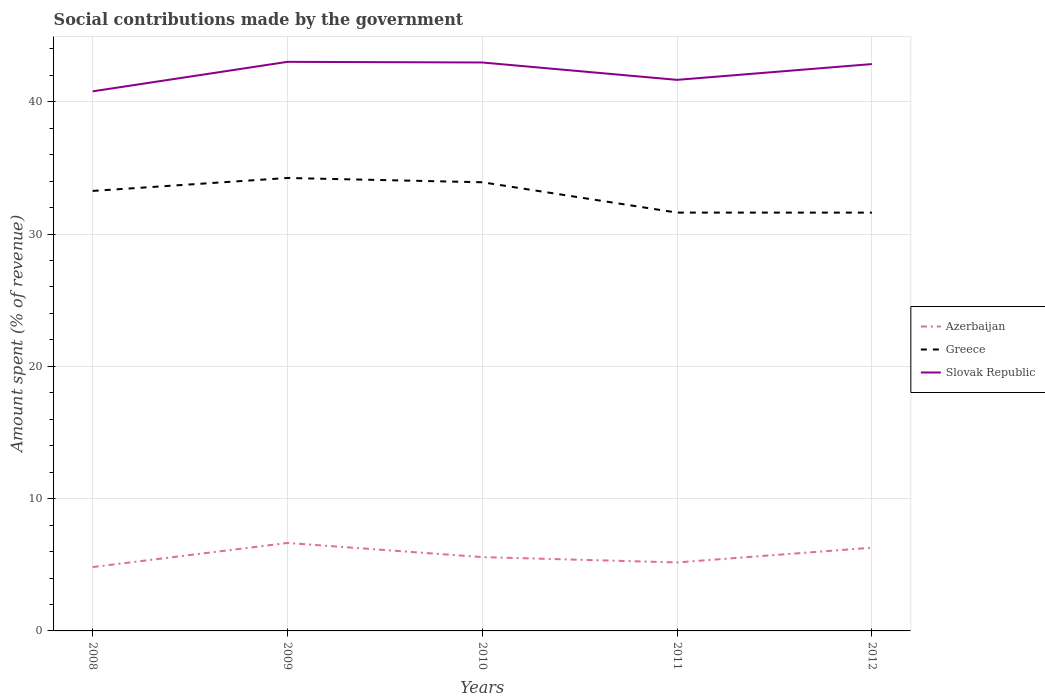Across all years, what is the maximum amount spent (in %) on social contributions in Slovak Republic?
Offer a terse response. 40.79. What is the total amount spent (in %) on social contributions in Azerbaijan in the graph?
Keep it short and to the point. 0.36. What is the difference between the highest and the second highest amount spent (in %) on social contributions in Azerbaijan?
Offer a very short reply. 1.82. What is the difference between the highest and the lowest amount spent (in %) on social contributions in Greece?
Ensure brevity in your answer.  3. Is the amount spent (in %) on social contributions in Greece strictly greater than the amount spent (in %) on social contributions in Slovak Republic over the years?
Keep it short and to the point. Yes. How many lines are there?
Offer a very short reply. 3. How many years are there in the graph?
Your answer should be very brief. 5. What is the difference between two consecutive major ticks on the Y-axis?
Your answer should be compact. 10. Are the values on the major ticks of Y-axis written in scientific E-notation?
Make the answer very short. No. Does the graph contain any zero values?
Make the answer very short. No. How many legend labels are there?
Your answer should be compact. 3. What is the title of the graph?
Your answer should be compact. Social contributions made by the government. Does "Channel Islands" appear as one of the legend labels in the graph?
Offer a terse response. No. What is the label or title of the Y-axis?
Provide a succinct answer. Amount spent (% of revenue). What is the Amount spent (% of revenue) of Azerbaijan in 2008?
Ensure brevity in your answer.  4.83. What is the Amount spent (% of revenue) in Greece in 2008?
Keep it short and to the point. 33.26. What is the Amount spent (% of revenue) of Slovak Republic in 2008?
Provide a succinct answer. 40.79. What is the Amount spent (% of revenue) of Azerbaijan in 2009?
Your response must be concise. 6.65. What is the Amount spent (% of revenue) in Greece in 2009?
Give a very brief answer. 34.24. What is the Amount spent (% of revenue) of Slovak Republic in 2009?
Ensure brevity in your answer.  43.02. What is the Amount spent (% of revenue) in Azerbaijan in 2010?
Make the answer very short. 5.58. What is the Amount spent (% of revenue) of Greece in 2010?
Your answer should be compact. 33.92. What is the Amount spent (% of revenue) of Slovak Republic in 2010?
Provide a short and direct response. 42.97. What is the Amount spent (% of revenue) of Azerbaijan in 2011?
Ensure brevity in your answer.  5.18. What is the Amount spent (% of revenue) of Greece in 2011?
Provide a short and direct response. 31.62. What is the Amount spent (% of revenue) in Slovak Republic in 2011?
Ensure brevity in your answer.  41.66. What is the Amount spent (% of revenue) of Azerbaijan in 2012?
Provide a short and direct response. 6.29. What is the Amount spent (% of revenue) of Greece in 2012?
Give a very brief answer. 31.62. What is the Amount spent (% of revenue) in Slovak Republic in 2012?
Your response must be concise. 42.85. Across all years, what is the maximum Amount spent (% of revenue) of Azerbaijan?
Offer a terse response. 6.65. Across all years, what is the maximum Amount spent (% of revenue) of Greece?
Give a very brief answer. 34.24. Across all years, what is the maximum Amount spent (% of revenue) of Slovak Republic?
Ensure brevity in your answer.  43.02. Across all years, what is the minimum Amount spent (% of revenue) of Azerbaijan?
Your answer should be very brief. 4.83. Across all years, what is the minimum Amount spent (% of revenue) of Greece?
Your response must be concise. 31.62. Across all years, what is the minimum Amount spent (% of revenue) in Slovak Republic?
Offer a very short reply. 40.79. What is the total Amount spent (% of revenue) in Azerbaijan in the graph?
Your answer should be very brief. 28.53. What is the total Amount spent (% of revenue) in Greece in the graph?
Offer a terse response. 164.66. What is the total Amount spent (% of revenue) in Slovak Republic in the graph?
Provide a succinct answer. 211.28. What is the difference between the Amount spent (% of revenue) of Azerbaijan in 2008 and that in 2009?
Give a very brief answer. -1.82. What is the difference between the Amount spent (% of revenue) of Greece in 2008 and that in 2009?
Give a very brief answer. -0.98. What is the difference between the Amount spent (% of revenue) in Slovak Republic in 2008 and that in 2009?
Provide a short and direct response. -2.23. What is the difference between the Amount spent (% of revenue) of Azerbaijan in 2008 and that in 2010?
Give a very brief answer. -0.75. What is the difference between the Amount spent (% of revenue) in Greece in 2008 and that in 2010?
Your answer should be compact. -0.66. What is the difference between the Amount spent (% of revenue) of Slovak Republic in 2008 and that in 2010?
Keep it short and to the point. -2.18. What is the difference between the Amount spent (% of revenue) in Azerbaijan in 2008 and that in 2011?
Give a very brief answer. -0.35. What is the difference between the Amount spent (% of revenue) in Greece in 2008 and that in 2011?
Offer a very short reply. 1.64. What is the difference between the Amount spent (% of revenue) of Slovak Republic in 2008 and that in 2011?
Provide a short and direct response. -0.87. What is the difference between the Amount spent (% of revenue) in Azerbaijan in 2008 and that in 2012?
Make the answer very short. -1.46. What is the difference between the Amount spent (% of revenue) in Greece in 2008 and that in 2012?
Give a very brief answer. 1.64. What is the difference between the Amount spent (% of revenue) of Slovak Republic in 2008 and that in 2012?
Make the answer very short. -2.06. What is the difference between the Amount spent (% of revenue) of Azerbaijan in 2009 and that in 2010?
Offer a terse response. 1.07. What is the difference between the Amount spent (% of revenue) in Greece in 2009 and that in 2010?
Your answer should be very brief. 0.32. What is the difference between the Amount spent (% of revenue) of Slovak Republic in 2009 and that in 2010?
Ensure brevity in your answer.  0.05. What is the difference between the Amount spent (% of revenue) in Azerbaijan in 2009 and that in 2011?
Give a very brief answer. 1.47. What is the difference between the Amount spent (% of revenue) of Greece in 2009 and that in 2011?
Ensure brevity in your answer.  2.62. What is the difference between the Amount spent (% of revenue) in Slovak Republic in 2009 and that in 2011?
Provide a succinct answer. 1.36. What is the difference between the Amount spent (% of revenue) in Azerbaijan in 2009 and that in 2012?
Offer a terse response. 0.36. What is the difference between the Amount spent (% of revenue) of Greece in 2009 and that in 2012?
Give a very brief answer. 2.62. What is the difference between the Amount spent (% of revenue) in Slovak Republic in 2009 and that in 2012?
Your answer should be very brief. 0.17. What is the difference between the Amount spent (% of revenue) in Azerbaijan in 2010 and that in 2011?
Make the answer very short. 0.4. What is the difference between the Amount spent (% of revenue) in Greece in 2010 and that in 2011?
Your answer should be very brief. 2.29. What is the difference between the Amount spent (% of revenue) in Slovak Republic in 2010 and that in 2011?
Provide a succinct answer. 1.31. What is the difference between the Amount spent (% of revenue) in Azerbaijan in 2010 and that in 2012?
Provide a succinct answer. -0.71. What is the difference between the Amount spent (% of revenue) in Greece in 2010 and that in 2012?
Provide a short and direct response. 2.3. What is the difference between the Amount spent (% of revenue) of Slovak Republic in 2010 and that in 2012?
Keep it short and to the point. 0.12. What is the difference between the Amount spent (% of revenue) in Azerbaijan in 2011 and that in 2012?
Ensure brevity in your answer.  -1.11. What is the difference between the Amount spent (% of revenue) in Greece in 2011 and that in 2012?
Your answer should be compact. 0. What is the difference between the Amount spent (% of revenue) of Slovak Republic in 2011 and that in 2012?
Keep it short and to the point. -1.19. What is the difference between the Amount spent (% of revenue) of Azerbaijan in 2008 and the Amount spent (% of revenue) of Greece in 2009?
Your answer should be very brief. -29.41. What is the difference between the Amount spent (% of revenue) in Azerbaijan in 2008 and the Amount spent (% of revenue) in Slovak Republic in 2009?
Give a very brief answer. -38.19. What is the difference between the Amount spent (% of revenue) in Greece in 2008 and the Amount spent (% of revenue) in Slovak Republic in 2009?
Keep it short and to the point. -9.76. What is the difference between the Amount spent (% of revenue) in Azerbaijan in 2008 and the Amount spent (% of revenue) in Greece in 2010?
Keep it short and to the point. -29.09. What is the difference between the Amount spent (% of revenue) of Azerbaijan in 2008 and the Amount spent (% of revenue) of Slovak Republic in 2010?
Ensure brevity in your answer.  -38.14. What is the difference between the Amount spent (% of revenue) in Greece in 2008 and the Amount spent (% of revenue) in Slovak Republic in 2010?
Provide a succinct answer. -9.71. What is the difference between the Amount spent (% of revenue) of Azerbaijan in 2008 and the Amount spent (% of revenue) of Greece in 2011?
Give a very brief answer. -26.79. What is the difference between the Amount spent (% of revenue) in Azerbaijan in 2008 and the Amount spent (% of revenue) in Slovak Republic in 2011?
Your answer should be compact. -36.83. What is the difference between the Amount spent (% of revenue) in Greece in 2008 and the Amount spent (% of revenue) in Slovak Republic in 2011?
Provide a succinct answer. -8.4. What is the difference between the Amount spent (% of revenue) of Azerbaijan in 2008 and the Amount spent (% of revenue) of Greece in 2012?
Offer a terse response. -26.79. What is the difference between the Amount spent (% of revenue) of Azerbaijan in 2008 and the Amount spent (% of revenue) of Slovak Republic in 2012?
Provide a short and direct response. -38.02. What is the difference between the Amount spent (% of revenue) in Greece in 2008 and the Amount spent (% of revenue) in Slovak Republic in 2012?
Your answer should be compact. -9.59. What is the difference between the Amount spent (% of revenue) in Azerbaijan in 2009 and the Amount spent (% of revenue) in Greece in 2010?
Provide a short and direct response. -27.27. What is the difference between the Amount spent (% of revenue) of Azerbaijan in 2009 and the Amount spent (% of revenue) of Slovak Republic in 2010?
Your answer should be very brief. -36.32. What is the difference between the Amount spent (% of revenue) in Greece in 2009 and the Amount spent (% of revenue) in Slovak Republic in 2010?
Make the answer very short. -8.73. What is the difference between the Amount spent (% of revenue) of Azerbaijan in 2009 and the Amount spent (% of revenue) of Greece in 2011?
Provide a short and direct response. -24.97. What is the difference between the Amount spent (% of revenue) in Azerbaijan in 2009 and the Amount spent (% of revenue) in Slovak Republic in 2011?
Offer a very short reply. -35.01. What is the difference between the Amount spent (% of revenue) in Greece in 2009 and the Amount spent (% of revenue) in Slovak Republic in 2011?
Provide a short and direct response. -7.42. What is the difference between the Amount spent (% of revenue) of Azerbaijan in 2009 and the Amount spent (% of revenue) of Greece in 2012?
Your answer should be compact. -24.97. What is the difference between the Amount spent (% of revenue) in Azerbaijan in 2009 and the Amount spent (% of revenue) in Slovak Republic in 2012?
Your answer should be very brief. -36.2. What is the difference between the Amount spent (% of revenue) in Greece in 2009 and the Amount spent (% of revenue) in Slovak Republic in 2012?
Your answer should be very brief. -8.61. What is the difference between the Amount spent (% of revenue) of Azerbaijan in 2010 and the Amount spent (% of revenue) of Greece in 2011?
Give a very brief answer. -26.04. What is the difference between the Amount spent (% of revenue) in Azerbaijan in 2010 and the Amount spent (% of revenue) in Slovak Republic in 2011?
Provide a succinct answer. -36.08. What is the difference between the Amount spent (% of revenue) of Greece in 2010 and the Amount spent (% of revenue) of Slovak Republic in 2011?
Provide a short and direct response. -7.74. What is the difference between the Amount spent (% of revenue) of Azerbaijan in 2010 and the Amount spent (% of revenue) of Greece in 2012?
Provide a succinct answer. -26.04. What is the difference between the Amount spent (% of revenue) in Azerbaijan in 2010 and the Amount spent (% of revenue) in Slovak Republic in 2012?
Your response must be concise. -37.27. What is the difference between the Amount spent (% of revenue) in Greece in 2010 and the Amount spent (% of revenue) in Slovak Republic in 2012?
Your answer should be very brief. -8.93. What is the difference between the Amount spent (% of revenue) in Azerbaijan in 2011 and the Amount spent (% of revenue) in Greece in 2012?
Ensure brevity in your answer.  -26.44. What is the difference between the Amount spent (% of revenue) in Azerbaijan in 2011 and the Amount spent (% of revenue) in Slovak Republic in 2012?
Give a very brief answer. -37.67. What is the difference between the Amount spent (% of revenue) in Greece in 2011 and the Amount spent (% of revenue) in Slovak Republic in 2012?
Offer a very short reply. -11.23. What is the average Amount spent (% of revenue) in Azerbaijan per year?
Your answer should be compact. 5.71. What is the average Amount spent (% of revenue) of Greece per year?
Ensure brevity in your answer.  32.93. What is the average Amount spent (% of revenue) in Slovak Republic per year?
Give a very brief answer. 42.26. In the year 2008, what is the difference between the Amount spent (% of revenue) in Azerbaijan and Amount spent (% of revenue) in Greece?
Make the answer very short. -28.43. In the year 2008, what is the difference between the Amount spent (% of revenue) of Azerbaijan and Amount spent (% of revenue) of Slovak Republic?
Provide a short and direct response. -35.96. In the year 2008, what is the difference between the Amount spent (% of revenue) of Greece and Amount spent (% of revenue) of Slovak Republic?
Your answer should be compact. -7.53. In the year 2009, what is the difference between the Amount spent (% of revenue) of Azerbaijan and Amount spent (% of revenue) of Greece?
Your answer should be compact. -27.59. In the year 2009, what is the difference between the Amount spent (% of revenue) of Azerbaijan and Amount spent (% of revenue) of Slovak Republic?
Give a very brief answer. -36.37. In the year 2009, what is the difference between the Amount spent (% of revenue) in Greece and Amount spent (% of revenue) in Slovak Republic?
Give a very brief answer. -8.78. In the year 2010, what is the difference between the Amount spent (% of revenue) of Azerbaijan and Amount spent (% of revenue) of Greece?
Your response must be concise. -28.34. In the year 2010, what is the difference between the Amount spent (% of revenue) in Azerbaijan and Amount spent (% of revenue) in Slovak Republic?
Your answer should be compact. -37.39. In the year 2010, what is the difference between the Amount spent (% of revenue) in Greece and Amount spent (% of revenue) in Slovak Republic?
Offer a very short reply. -9.05. In the year 2011, what is the difference between the Amount spent (% of revenue) in Azerbaijan and Amount spent (% of revenue) in Greece?
Your answer should be very brief. -26.44. In the year 2011, what is the difference between the Amount spent (% of revenue) in Azerbaijan and Amount spent (% of revenue) in Slovak Republic?
Ensure brevity in your answer.  -36.48. In the year 2011, what is the difference between the Amount spent (% of revenue) of Greece and Amount spent (% of revenue) of Slovak Republic?
Your answer should be compact. -10.03. In the year 2012, what is the difference between the Amount spent (% of revenue) of Azerbaijan and Amount spent (% of revenue) of Greece?
Provide a succinct answer. -25.33. In the year 2012, what is the difference between the Amount spent (% of revenue) in Azerbaijan and Amount spent (% of revenue) in Slovak Republic?
Your response must be concise. -36.56. In the year 2012, what is the difference between the Amount spent (% of revenue) of Greece and Amount spent (% of revenue) of Slovak Republic?
Provide a succinct answer. -11.23. What is the ratio of the Amount spent (% of revenue) in Azerbaijan in 2008 to that in 2009?
Your answer should be very brief. 0.73. What is the ratio of the Amount spent (% of revenue) in Greece in 2008 to that in 2009?
Offer a terse response. 0.97. What is the ratio of the Amount spent (% of revenue) in Slovak Republic in 2008 to that in 2009?
Your response must be concise. 0.95. What is the ratio of the Amount spent (% of revenue) in Azerbaijan in 2008 to that in 2010?
Make the answer very short. 0.87. What is the ratio of the Amount spent (% of revenue) of Greece in 2008 to that in 2010?
Your answer should be very brief. 0.98. What is the ratio of the Amount spent (% of revenue) of Slovak Republic in 2008 to that in 2010?
Offer a terse response. 0.95. What is the ratio of the Amount spent (% of revenue) in Azerbaijan in 2008 to that in 2011?
Your answer should be very brief. 0.93. What is the ratio of the Amount spent (% of revenue) of Greece in 2008 to that in 2011?
Provide a succinct answer. 1.05. What is the ratio of the Amount spent (% of revenue) of Slovak Republic in 2008 to that in 2011?
Offer a very short reply. 0.98. What is the ratio of the Amount spent (% of revenue) in Azerbaijan in 2008 to that in 2012?
Offer a terse response. 0.77. What is the ratio of the Amount spent (% of revenue) in Greece in 2008 to that in 2012?
Offer a terse response. 1.05. What is the ratio of the Amount spent (% of revenue) of Slovak Republic in 2008 to that in 2012?
Provide a succinct answer. 0.95. What is the ratio of the Amount spent (% of revenue) of Azerbaijan in 2009 to that in 2010?
Offer a terse response. 1.19. What is the ratio of the Amount spent (% of revenue) of Greece in 2009 to that in 2010?
Provide a short and direct response. 1.01. What is the ratio of the Amount spent (% of revenue) in Azerbaijan in 2009 to that in 2011?
Your answer should be very brief. 1.28. What is the ratio of the Amount spent (% of revenue) of Greece in 2009 to that in 2011?
Offer a very short reply. 1.08. What is the ratio of the Amount spent (% of revenue) in Slovak Republic in 2009 to that in 2011?
Your answer should be very brief. 1.03. What is the ratio of the Amount spent (% of revenue) of Azerbaijan in 2009 to that in 2012?
Your response must be concise. 1.06. What is the ratio of the Amount spent (% of revenue) in Greece in 2009 to that in 2012?
Your answer should be very brief. 1.08. What is the ratio of the Amount spent (% of revenue) in Slovak Republic in 2009 to that in 2012?
Give a very brief answer. 1. What is the ratio of the Amount spent (% of revenue) of Azerbaijan in 2010 to that in 2011?
Provide a succinct answer. 1.08. What is the ratio of the Amount spent (% of revenue) in Greece in 2010 to that in 2011?
Offer a terse response. 1.07. What is the ratio of the Amount spent (% of revenue) in Slovak Republic in 2010 to that in 2011?
Offer a very short reply. 1.03. What is the ratio of the Amount spent (% of revenue) in Azerbaijan in 2010 to that in 2012?
Make the answer very short. 0.89. What is the ratio of the Amount spent (% of revenue) of Greece in 2010 to that in 2012?
Ensure brevity in your answer.  1.07. What is the ratio of the Amount spent (% of revenue) of Slovak Republic in 2010 to that in 2012?
Provide a short and direct response. 1. What is the ratio of the Amount spent (% of revenue) of Azerbaijan in 2011 to that in 2012?
Make the answer very short. 0.82. What is the ratio of the Amount spent (% of revenue) in Slovak Republic in 2011 to that in 2012?
Offer a very short reply. 0.97. What is the difference between the highest and the second highest Amount spent (% of revenue) of Azerbaijan?
Your answer should be compact. 0.36. What is the difference between the highest and the second highest Amount spent (% of revenue) of Greece?
Give a very brief answer. 0.32. What is the difference between the highest and the second highest Amount spent (% of revenue) in Slovak Republic?
Keep it short and to the point. 0.05. What is the difference between the highest and the lowest Amount spent (% of revenue) in Azerbaijan?
Provide a short and direct response. 1.82. What is the difference between the highest and the lowest Amount spent (% of revenue) of Greece?
Provide a succinct answer. 2.62. What is the difference between the highest and the lowest Amount spent (% of revenue) of Slovak Republic?
Your response must be concise. 2.23. 